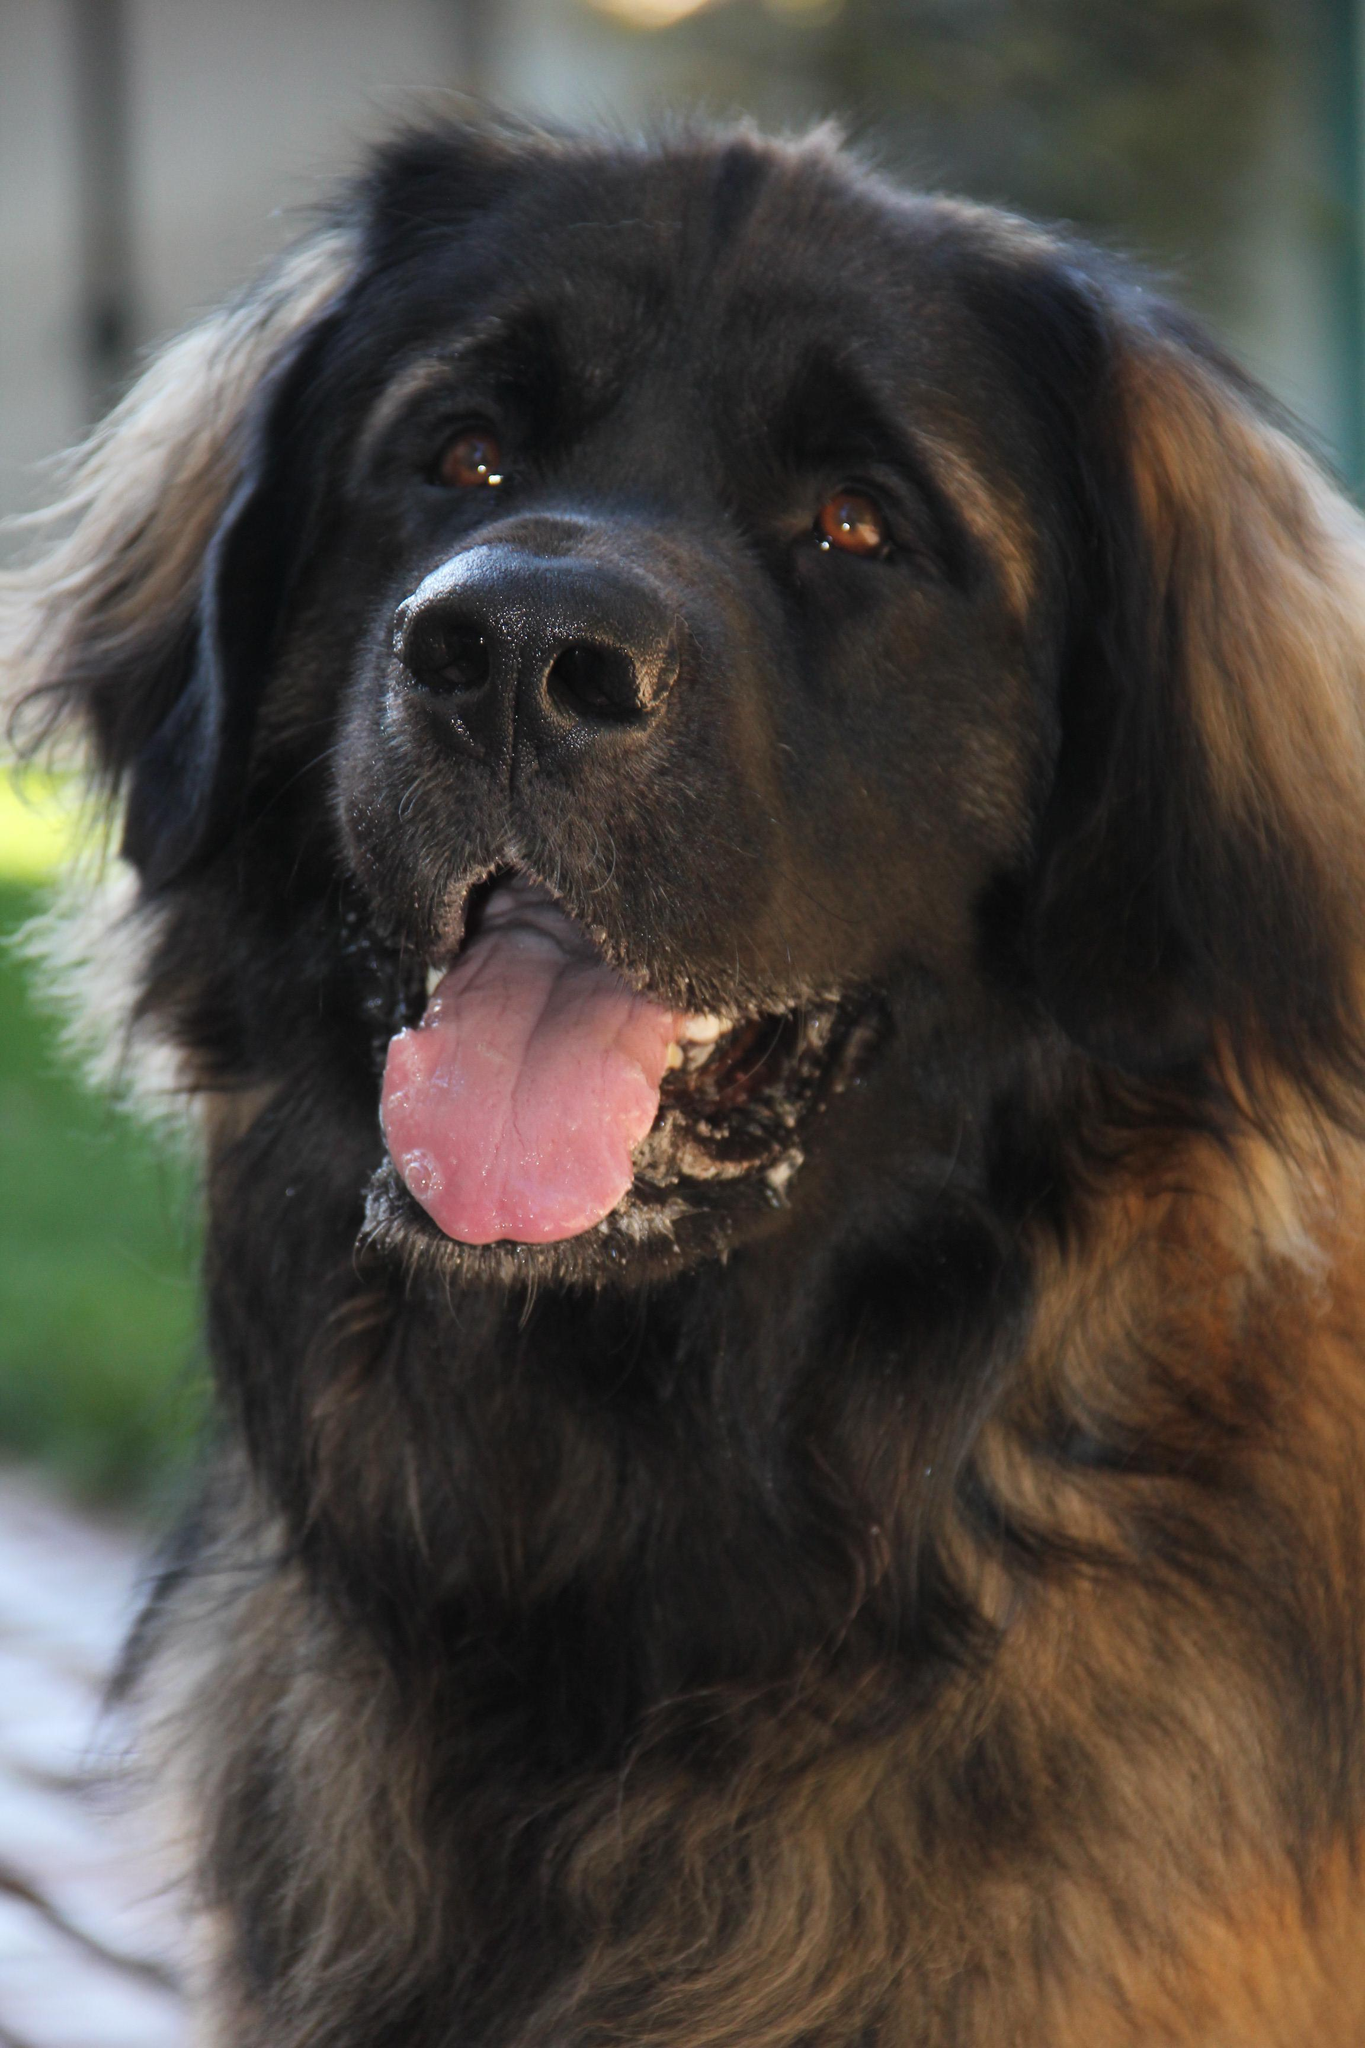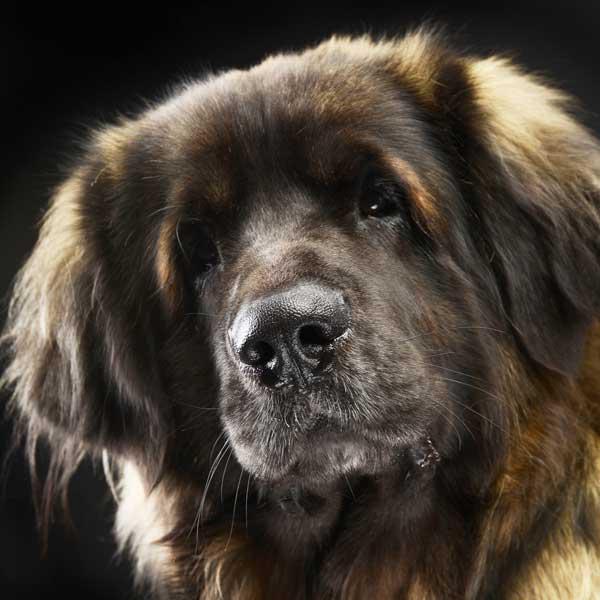The first image is the image on the left, the second image is the image on the right. For the images shown, is this caption "A dog is being touched by a human in one of the images." true? Answer yes or no. No. The first image is the image on the left, the second image is the image on the right. Analyze the images presented: Is the assertion "Exactly one of the dogs is shown standing in profile on all fours in the grass." valid? Answer yes or no. No. 